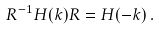Convert formula to latex. <formula><loc_0><loc_0><loc_500><loc_500>R ^ { - 1 } H ( k ) R = H ( - k ) \, .</formula> 